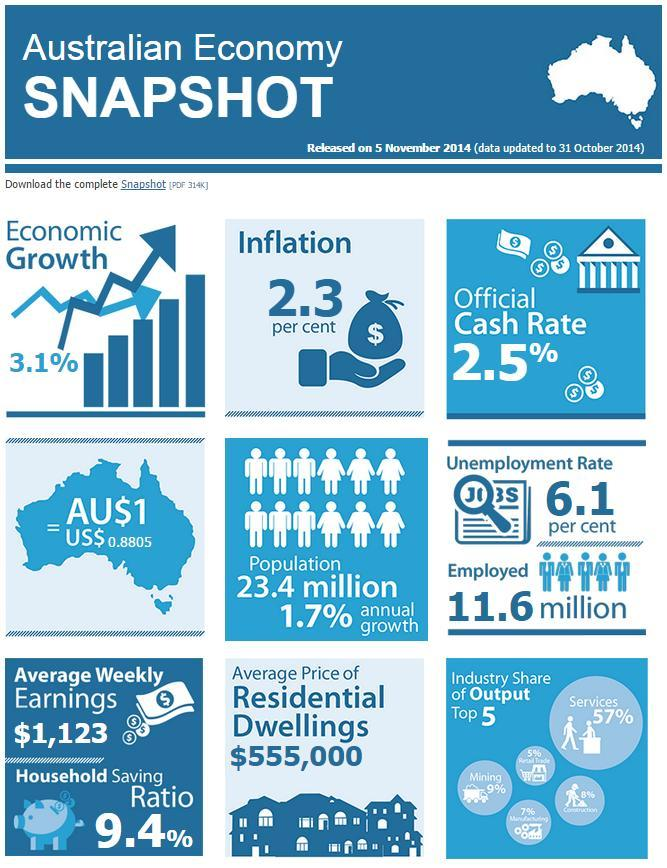What is the equivalent of one Australian dollar in US dollars?
Answer the question with a short phrase. 0.8805 Which has the highest industry share among manufacturing, construction, and retail trade? Construction Which has the industry has the second highest share of output ? Mining 